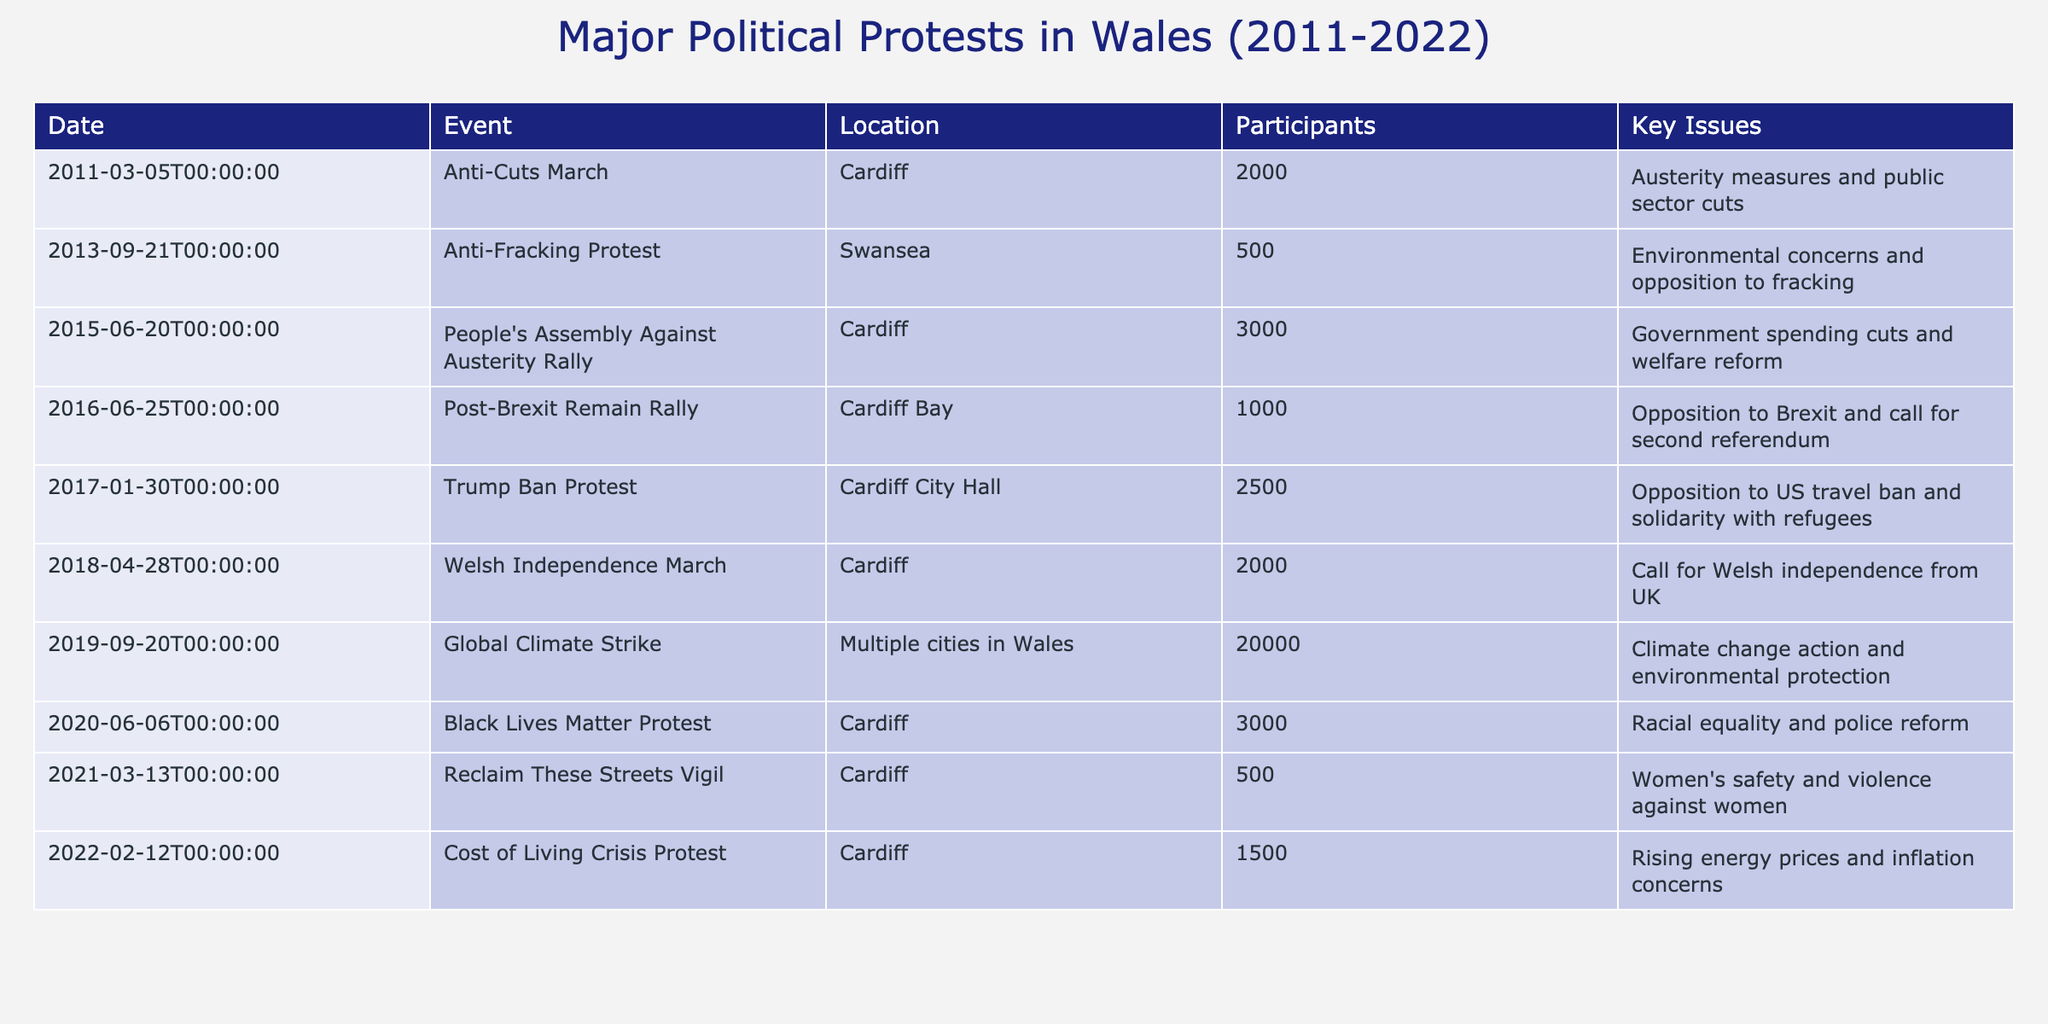What was the date of the Black Lives Matter Protest? The table lists events by date, and the row for the Black Lives Matter Protest shows it occurred on June 6, 2020.
Answer: June 6, 2020 How many participants were there in the Global Climate Strike? The table indicates that the Global Climate Strike had 20,000 participants, as stated in the row corresponding to the event.
Answer: 20,000 What are the two issues addressed in the Anti-Cuts March? The Anti-Cuts March event row states the key issue as "Austerity measures and public sector cuts," presenting a single issue but indicating broader themes of economic and governmental policy.
Answer: Austerity measures and public sector cuts How many protests had over 2000 participants? By examining the participant counts in the table, the events that had over 2000 participants are: 2011 Anti-Cuts March (2000), 2015 People's Assembly Against Austerity Rally (3000), 2017 Trump Ban Protest (2500), 2018 Welsh Independence March (2000), and 2019 Global Climate Strike (20000). Thus, out of the 10 events, 4 had over 2000 participants.
Answer: 4 Did any protests address issues related to women’s safety? Looking at the key issues in the table, the event labeled as the "Reclaim These Streets Vigil" clearly addresses women's safety and violence against women. Thus, there is at least one event that addresses this concern.
Answer: Yes What was the average number of participants across all listed events? To find the average, first, we sum up the number of participants from all events: 2000 + 500 + 3000 + 1000 + 2500 + 2000 + 20000 + 3000 + 500 + 1500 = 31000. There are 10 events, so we divide the total by 10: 31000 / 10 = 3100.
Answer: 3100 Which protest had the highest number of participants, and what were the key issues? The table shows the Global Climate Strike had the highest number of participants, with 20,000. The key issues addressed were climate change action and environmental protection, as specified in the row of that event.
Answer: Global Climate Strike; Climate change action and environmental protection Comparing the Trump Ban Protest and the Anti-Fracking Protest, which had more participants and by how much? The Trump Ban Protest had 2500 participants and the Anti-Fracking Protest had 500 participants. The difference is found by subtracting the number of Anti-Fracking Protest participants from the Trump Ban Protest's figures: 2500 - 500 = 2000.
Answer: 2000 What were the locations of the protests addressing austerity measures? The table indicates that two protests addressed austerity measures—the Anti-Cuts March and the People's Assembly Against Austerity Rally. Both events took place in Cardiff.
Answer: Cardiff 